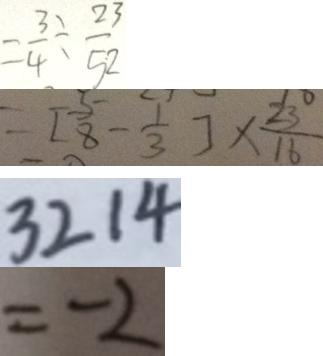<formula> <loc_0><loc_0><loc_500><loc_500>= \frac { 3 } { 4 } \div \frac { 2 3 } { 5 2 } 
 = [ \frac { 5 } { 8 } - \frac { 1 } { 3 } ] \times \frac { 2 3 } { 1 6 } 
 3 2 1 4 
 = - 2</formula> 